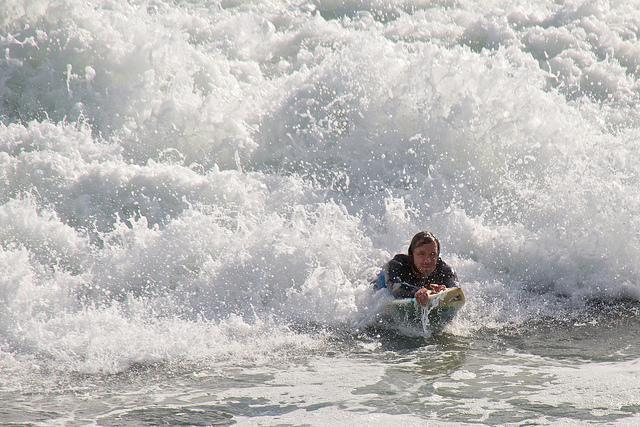How many black cars are there?
Give a very brief answer. 0. 